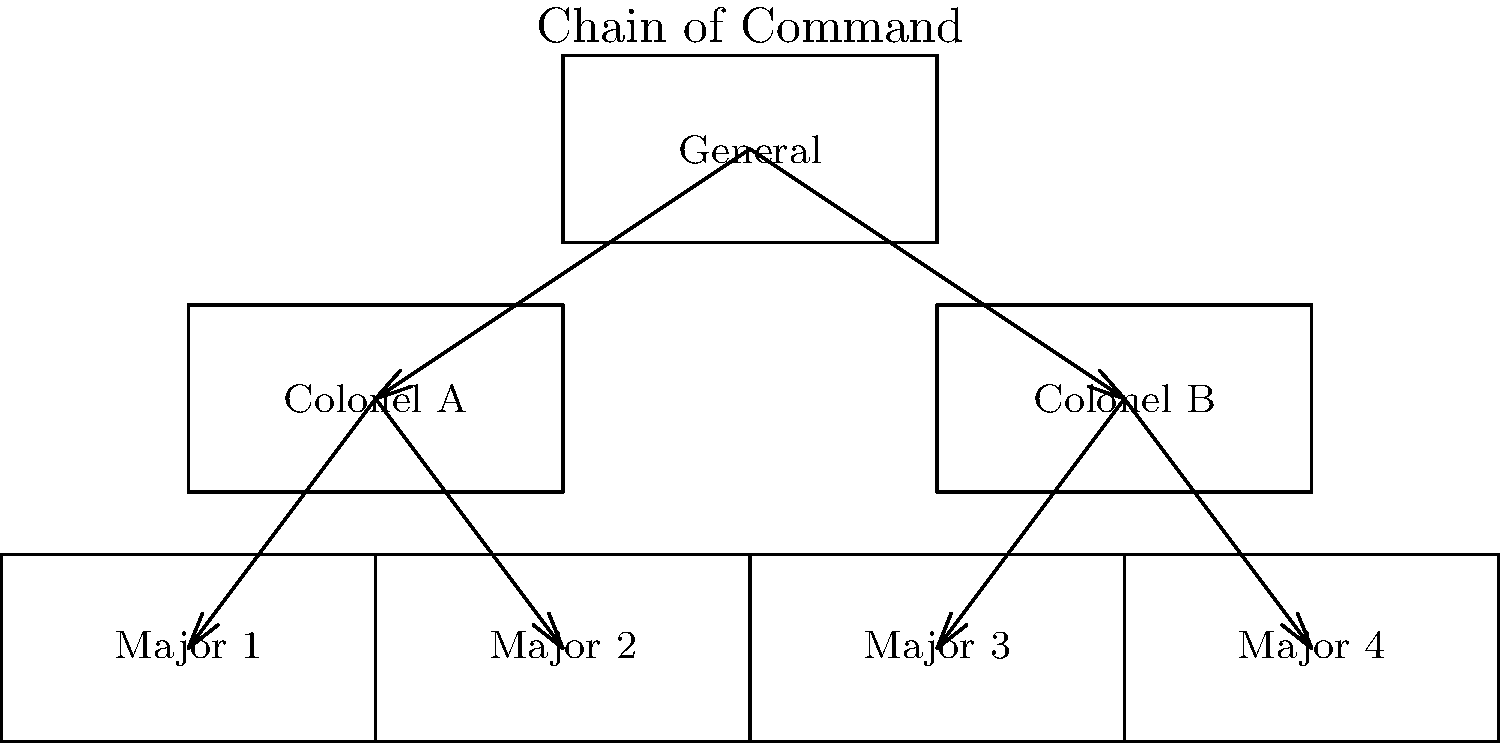In the given military organizational chart, how many officers are directly under the command of Colonel A? To answer this question, we need to analyze the organizational chart step-by-step:

1. Identify the position of Colonel A in the chart.
   - Colonel A is on the left side of the chart, directly below the General.

2. Look for the officers directly connected to Colonel A with downward arrows.
   - We can see two arrows pointing down from Colonel A.

3. Count the number of officers at the end of these arrows.
   - The arrows from Colonel A point to Major 1 and Major 2.

4. Verify that there are no other officers directly connected to Colonel A.
   - There are no other officers connected to Colonel A.

5. Sum up the total number of officers directly under Colonel A's command.
   - We counted two officers: Major 1 and Major 2.

Therefore, Colonel A directly commands two officers according to this organizational chart.
Answer: 2 officers 